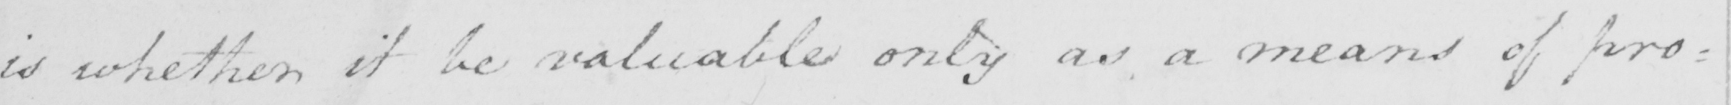What does this handwritten line say? is whether it be valuable only as a means of pro= 